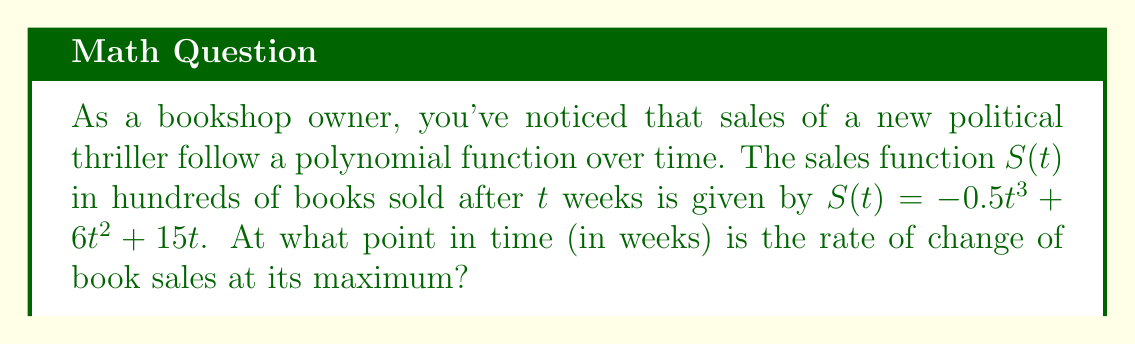Could you help me with this problem? To find the maximum rate of change, we need to follow these steps:

1) First, we need to find the rate of change function, which is the first derivative of $S(t)$:

   $S'(t) = -1.5t^2 + 12t + 15$

2) The maximum rate of change will occur at the point where the second derivative equals zero. So, let's find the second derivative:

   $S''(t) = -3t + 12$

3) Now, set $S''(t) = 0$ and solve for $t$:

   $-3t + 12 = 0$
   $-3t = -12$
   $t = 4$

4) To confirm this is a maximum (not a minimum), we can check the sign of $S'''(t)$:

   $S'''(t) = -3$

   Since this is negative, we confirm that $t = 4$ gives a maximum rate of change.

Therefore, the rate of change of book sales is at its maximum 4 weeks after the release.
Answer: 4 weeks 